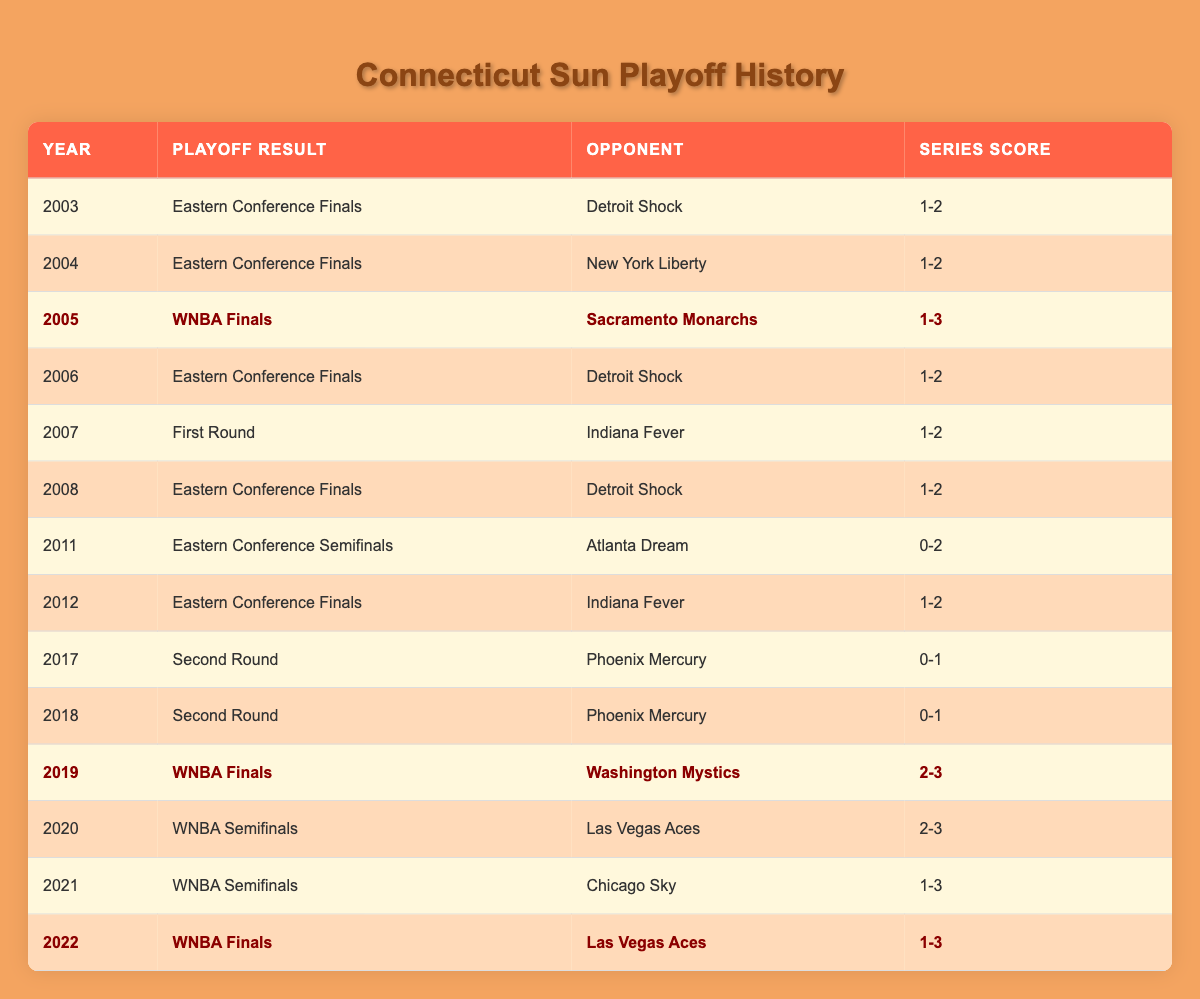What playoff result did the Connecticut Sun achieve in 2005? According to the table, in 2005, the Connecticut Sun reached the WNBA Finals.
Answer: WNBA Finals How many times did the Connecticut Sun face the Detroit Shock in the playoffs from 2003 to 2008? By examining the table, the Connecticut Sun faced the Detroit Shock three times in the playoffs: in 2003, 2006, and 2008.
Answer: 3 What was the series score in the 2019 WNBA Finals? Looking at the table, the series score for the Connecticut Sun in the 2019 WNBA Finals against the Washington Mystics was 2-3.
Answer: 2-3 Did the Connecticut Sun win any playoff series from 2003 to 2022? By checking the table, it is clear that the Connecticut Sun did not win any of their playoff series during that time frame, as all results indicate they lost their series.
Answer: No In how many years did the Connecticut Sun reach the Eastern Conference Finals from 2003 to 2012? Reviewing the table, the Connecticut Sun reached the Eastern Conference Finals six times from 2003 to 2012: in 2003, 2004, 2006, 2008, 2011, and 2012.
Answer: 6 What percentage of the playoff appearances resulted in reaching the WNBA Finals? The Connecticut Sun reached the WNBA Finals in 2005, 2019, 2020, and 2022, which is 4 out of 14 playoff appearances. Calculating the percentage gives (4/14) * 100 = approximately 28.57%.
Answer: 28.57% During which year did the Connecticut Sun lose in the Eastern Conference Semifinals? According to the table, the Connecticut Sun lost in the Eastern Conference Semifinals in 2011 to the Atlanta Dream.
Answer: 2011 How many playoff appearances did the Connecticut Sun have between 2007 and 2019? From 2007 to 2019, the Connecticut Sun had playoff appearances in 2008, 2011, 2012, 2017, 2018, and 2019, summing up to 6 appearances during that span.
Answer: 6 What is the overall trend in the Connecticut Sun's playoff results from 2003 to 2022 based on the series scores? Analyzing the data, the Connecticut Sun consistently faced tough competition; they lost in every playoff series except for 2019 and 2020 where they reached the WNBA Finals and Semifinals, respectively but lost both. This indicates a trend of strong playoff contention with limited success.
Answer: Consistent tough competition, limited success 